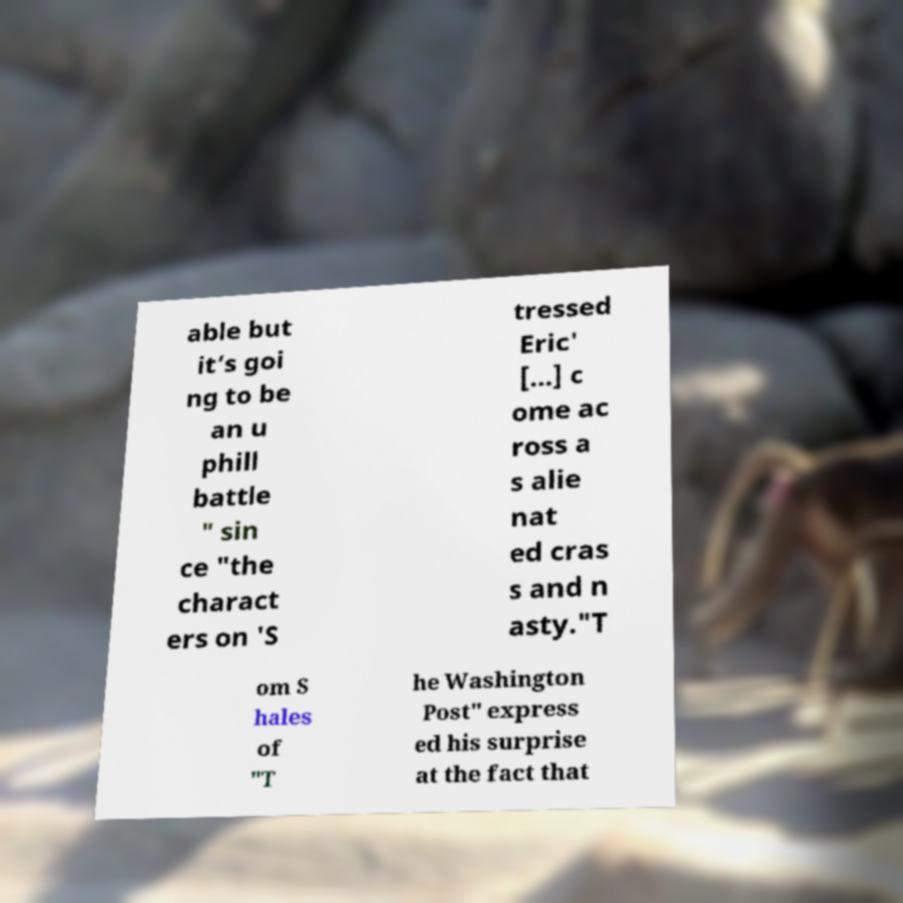Could you extract and type out the text from this image? able but it’s goi ng to be an u phill battle " sin ce "the charact ers on 'S tressed Eric' [...] c ome ac ross a s alie nat ed cras s and n asty."T om S hales of "T he Washington Post" express ed his surprise at the fact that 